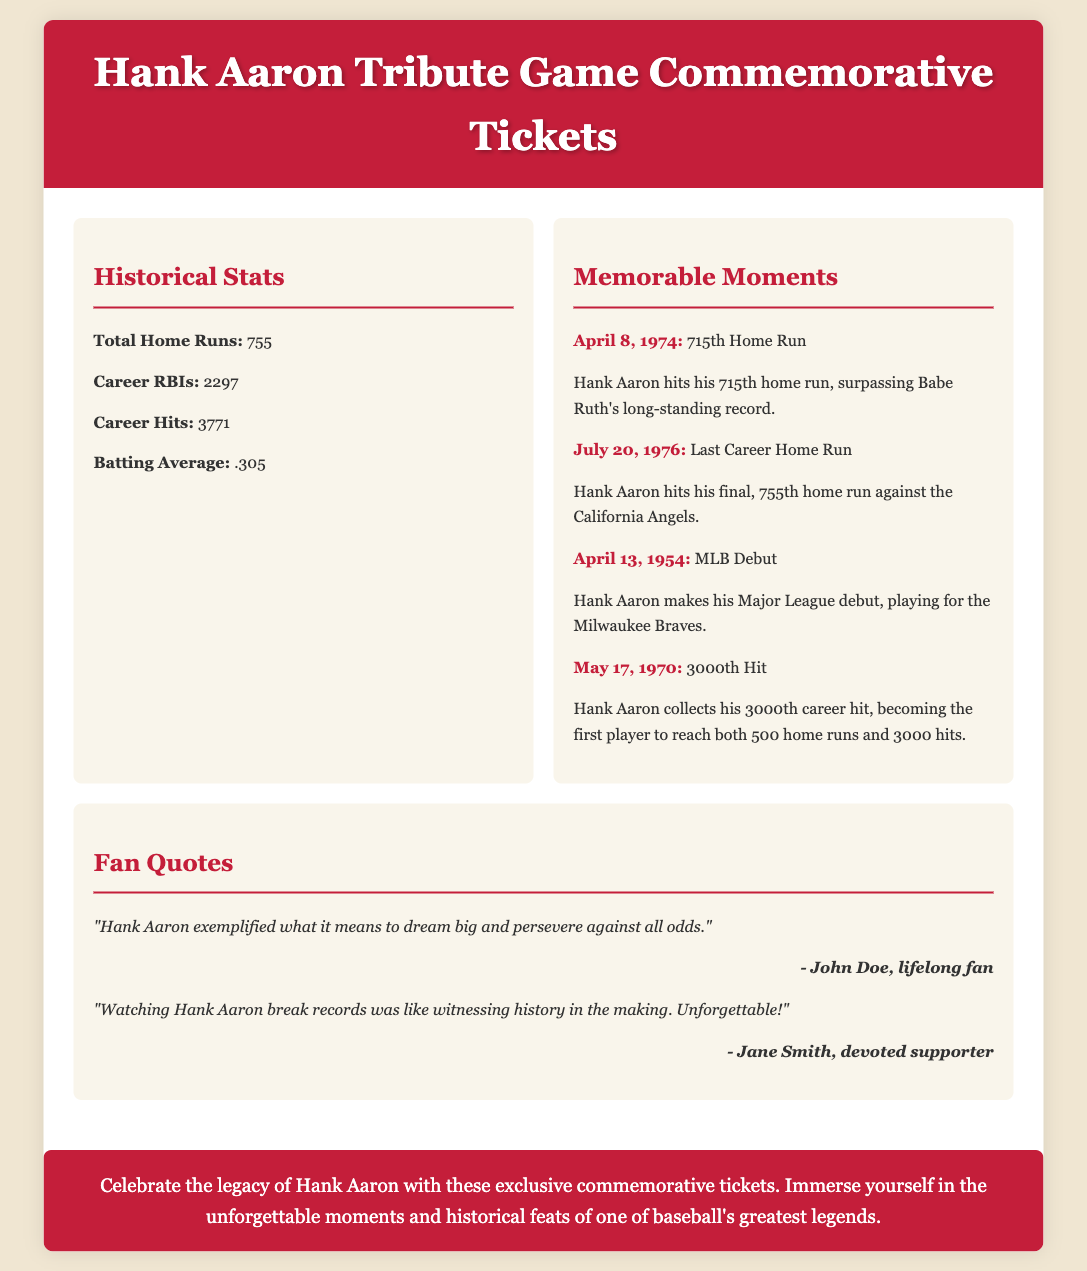What are the total home runs hit by Hank Aaron? The document provides specific historical stats, stating that Hank Aaron hit a total of 755 home runs.
Answer: 755 When did Hank Aaron hit his 715th home run? The document lists memorable moments, indicating that Hank Aaron hit his 715th home run on April 8, 1974.
Answer: April 8, 1974 How many career RBIs did Hank Aaron achieve? A specific statistical figure is given in the historical stats section, showing Hank Aaron's career RBIs as 2297.
Answer: 2297 What milestone did Hank Aaron achieve on May 17, 1970? The document highlights that on May 17, 1970, Hank Aaron collected his 3000th career hit, marking a significant achievement.
Answer: 3000th Hit Who was the first player to reach both 500 home runs and 3000 hits? Based on the memorable moments mentioned, Hank Aaron was the first player to achieve both feats.
Answer: Hank Aaron What is the background color of the document? The document's background color is specified as #f0e6d2, which is a light tan shade.
Answer: #f0e6d2 What is the main theme of the tribute message? The tribute message summarizes the purpose of the document, emphasizing the celebration of Hank Aaron's legacy and achievements.
Answer: Celebrate the legacy of Hank Aaron Who is quoted as saying Hank Aaron exemplified dreaming big? A quote from John Doe, a lifelong fan, describes Hank Aaron's qualities and impact on his admirers.
Answer: John Doe What is Hank Aaron's career batting average? The document lists Hank Aaron's career batting average as .305 in the historical stats section.
Answer: .305 